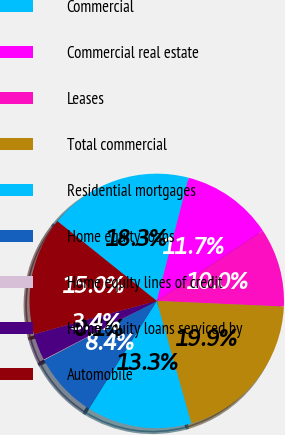Convert chart. <chart><loc_0><loc_0><loc_500><loc_500><pie_chart><fcel>Commercial<fcel>Commercial real estate<fcel>Leases<fcel>Total commercial<fcel>Residential mortgages<fcel>Home equity loans<fcel>Home equity lines of credit<fcel>Home equity loans serviced by<fcel>Automobile<nl><fcel>18.27%<fcel>11.66%<fcel>10.01%<fcel>19.92%<fcel>13.31%<fcel>8.36%<fcel>0.1%<fcel>3.4%<fcel>14.97%<nl></chart> 